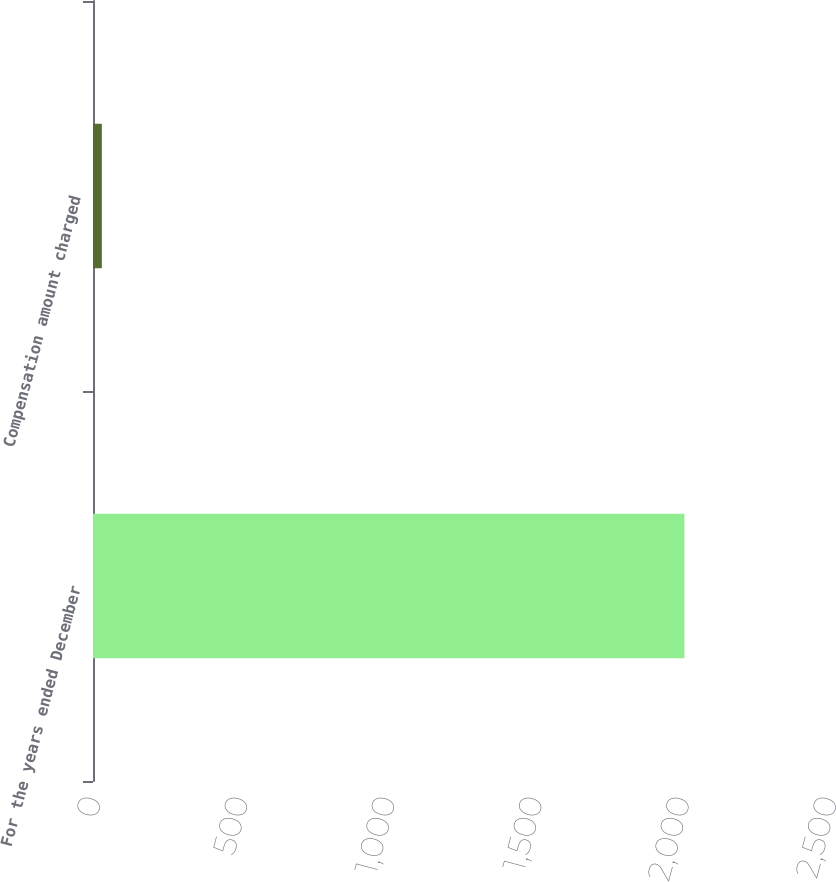Convert chart. <chart><loc_0><loc_0><loc_500><loc_500><bar_chart><fcel>For the years ended December<fcel>Compensation amount charged<nl><fcel>2009<fcel>30<nl></chart> 